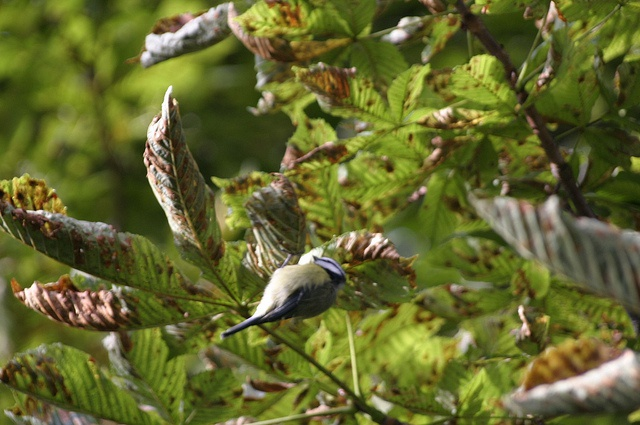Describe the objects in this image and their specific colors. I can see a bird in darkgreen, black, white, and gray tones in this image. 